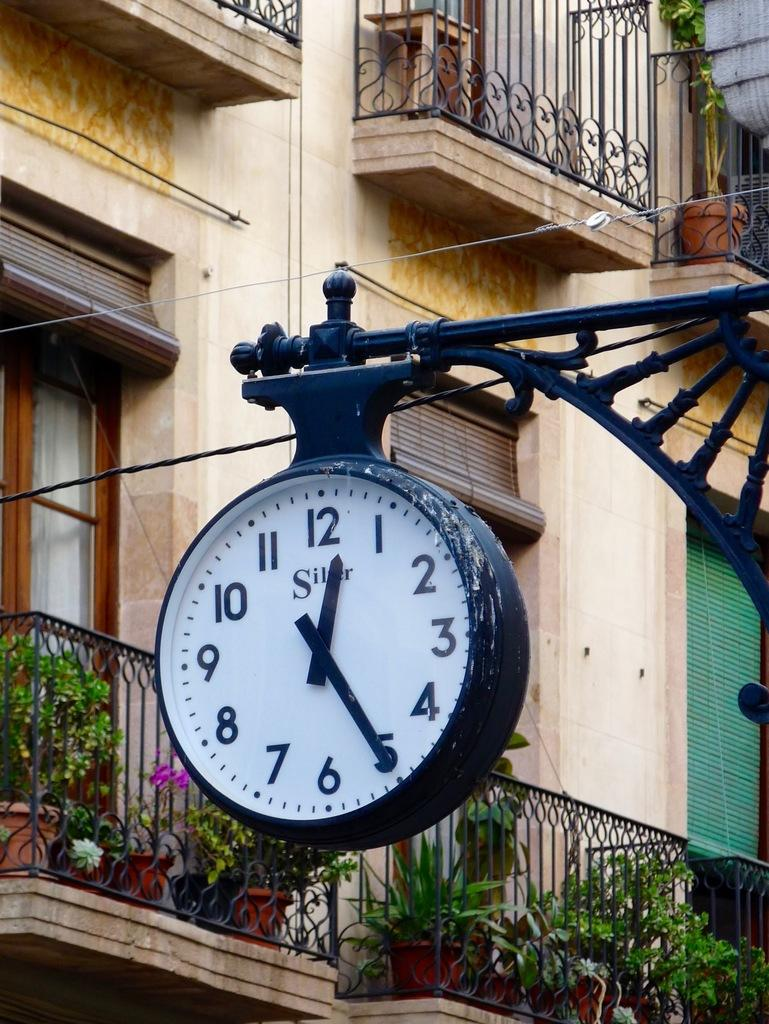<image>
Describe the image concisely. The time is shown as being twenty five past twelve on this hanging clock. 